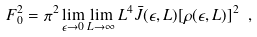Convert formula to latex. <formula><loc_0><loc_0><loc_500><loc_500>F ^ { 2 } _ { 0 } = \pi ^ { 2 } \lim _ { \epsilon \to 0 } \lim _ { L \to \infty } L ^ { 4 } \bar { J } ( \epsilon , L ) [ \rho ( \epsilon , L ) ] ^ { 2 } \ ,</formula> 